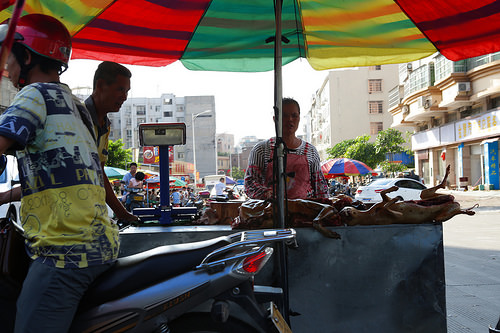<image>
Can you confirm if the umbrella is above the woman? Yes. The umbrella is positioned above the woman in the vertical space, higher up in the scene. 